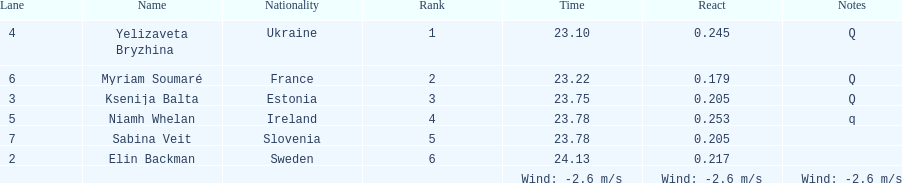Are any of the lanes in consecutive order? No. Would you mind parsing the complete table? {'header': ['Lane', 'Name', 'Nationality', 'Rank', 'Time', 'React', 'Notes'], 'rows': [['4', 'Yelizaveta Bryzhina', 'Ukraine', '1', '23.10', '0.245', 'Q'], ['6', 'Myriam Soumaré', 'France', '2', '23.22', '0.179', 'Q'], ['3', 'Ksenija Balta', 'Estonia', '3', '23.75', '0.205', 'Q'], ['5', 'Niamh Whelan', 'Ireland', '4', '23.78', '0.253', 'q'], ['7', 'Sabina Veit', 'Slovenia', '5', '23.78', '0.205', ''], ['2', 'Elin Backman', 'Sweden', '6', '24.13', '0.217', ''], ['', '', '', '', 'Wind: -2.6\xa0m/s', 'Wind: -2.6\xa0m/s', 'Wind: -2.6\xa0m/s']]} 